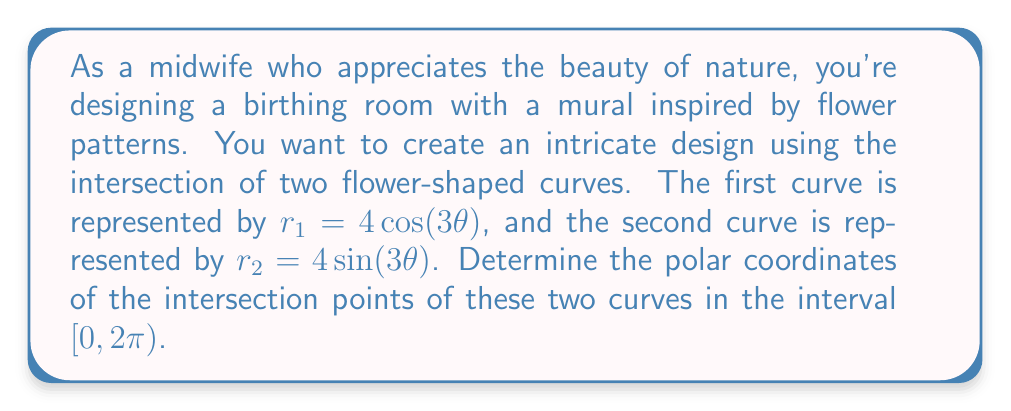Teach me how to tackle this problem. To find the intersection points of the two curves, we need to solve the equation:

$$4\cos(3\theta) = 4\sin(3\theta)$$

Dividing both sides by 4:

$$\cos(3\theta) = \sin(3\theta)$$

This equation is satisfied when:

$$3\theta = \frac{\pi}{4} + n\pi, \quad n = 0, 1, 2, ...$$

Solving for $\theta$:

$$\theta = \frac{\pi}{12} + \frac{n\pi}{3}, \quad n = 0, 1, 2, ...$$

In the interval $[0, 2\pi)$, we have 6 solutions:

1. $\theta_1 = \frac{\pi}{12}$ (when $n = 0$)
2. $\theta_2 = \frac{5\pi}{12}$ (when $n = 1$)
3. $\theta_3 = \frac{3\pi}{4}$ (when $n = 2$)
4. $\theta_4 = \frac{13\pi}{12}$ (when $n = 3$)
5. $\theta_5 = \frac{17\pi}{12}$ (when $n = 4$)
6. $\theta_6 = \frac{23\pi}{12}$ (when $n = 5$)

To find the r-coordinate for each point, we can use either $r_1$ or $r_2$ equation (they will give the same result at intersection points). Let's use $r_1 = 4\cos(3\theta)$:

1. $r_1 = 4\cos(3 \cdot \frac{\pi}{12}) = 4\cos(\frac{\pi}{4}) = 2\sqrt{2}$
2. $r_2 = 4\cos(3 \cdot \frac{5\pi}{12}) = 4\cos(\frac{5\pi}{4}) = -2\sqrt{2}$
3. $r_3 = 4\cos(3 \cdot \frac{3\pi}{4}) = 4\cos(\frac{9\pi}{4}) = 2\sqrt{2}$
4. $r_4 = 4\cos(3 \cdot \frac{13\pi}{12}) = 4\cos(\frac{13\pi}{4}) = -2\sqrt{2}$
5. $r_5 = 4\cos(3 \cdot \frac{17\pi}{12}) = 4\cos(\frac{17\pi}{4}) = 2\sqrt{2}$
6. $r_6 = 4\cos(3 \cdot \frac{23\pi}{12}) = 4\cos(\frac{23\pi}{4}) = -2\sqrt{2}$

Note that negative r-values in polar coordinates represent points on the opposite side of the pole, so we can convert them to positive r-values by adding $\pi$ to the corresponding $\theta$ value.
Answer: The intersection points in polar coordinates $(r, \theta)$ are:

1. $(2\sqrt{2}, \frac{\pi}{12})$
2. $(2\sqrt{2}, \frac{17\pi}{12})$
3. $(2\sqrt{2}, \frac{3\pi}{4})$
4. $(2\sqrt{2}, \frac{5\pi}{12})$
5. $(2\sqrt{2}, \frac{23\pi}{12})$
6. $(2\sqrt{2}, \frac{13\pi}{12})$ 